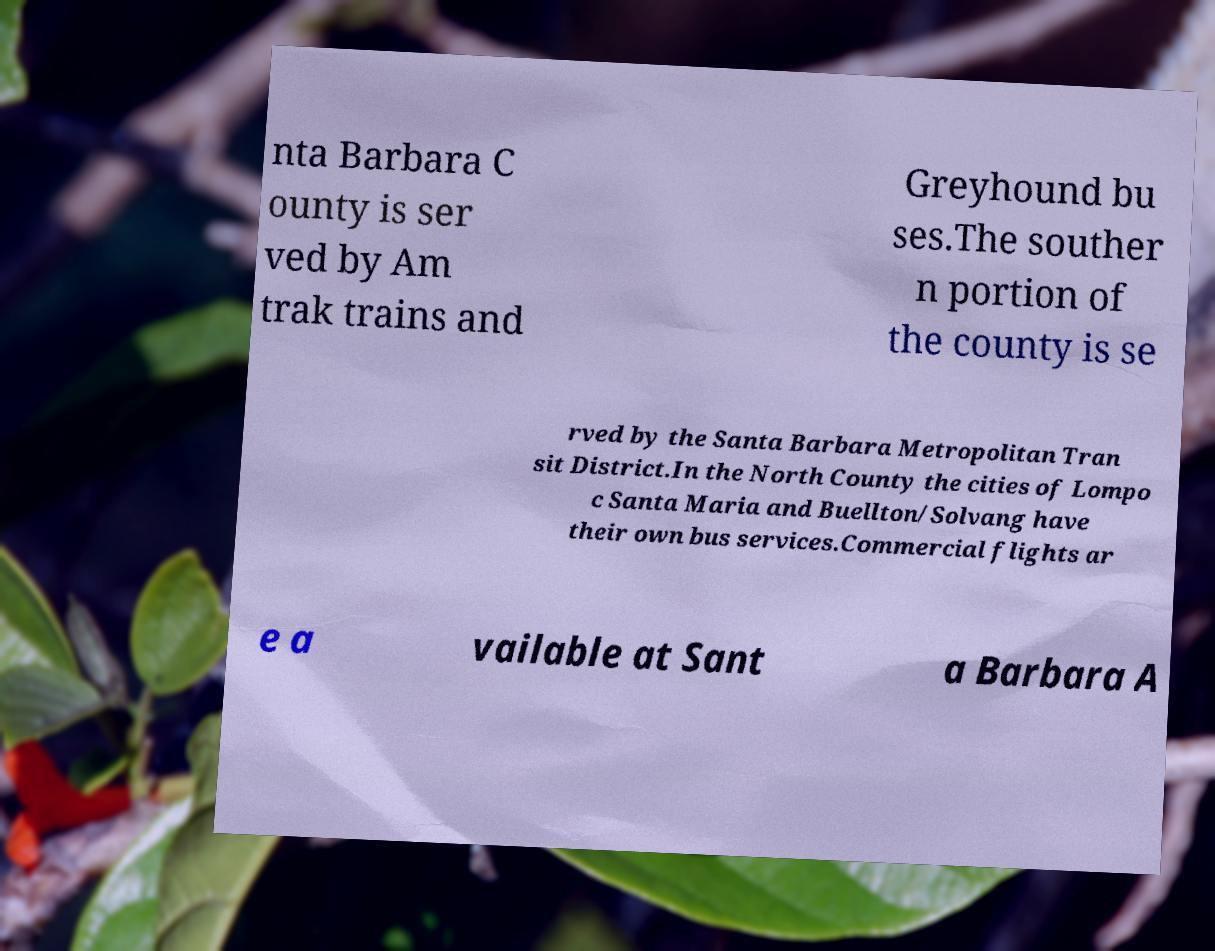Could you assist in decoding the text presented in this image and type it out clearly? nta Barbara C ounty is ser ved by Am trak trains and Greyhound bu ses.The souther n portion of the county is se rved by the Santa Barbara Metropolitan Tran sit District.In the North County the cities of Lompo c Santa Maria and Buellton/Solvang have their own bus services.Commercial flights ar e a vailable at Sant a Barbara A 